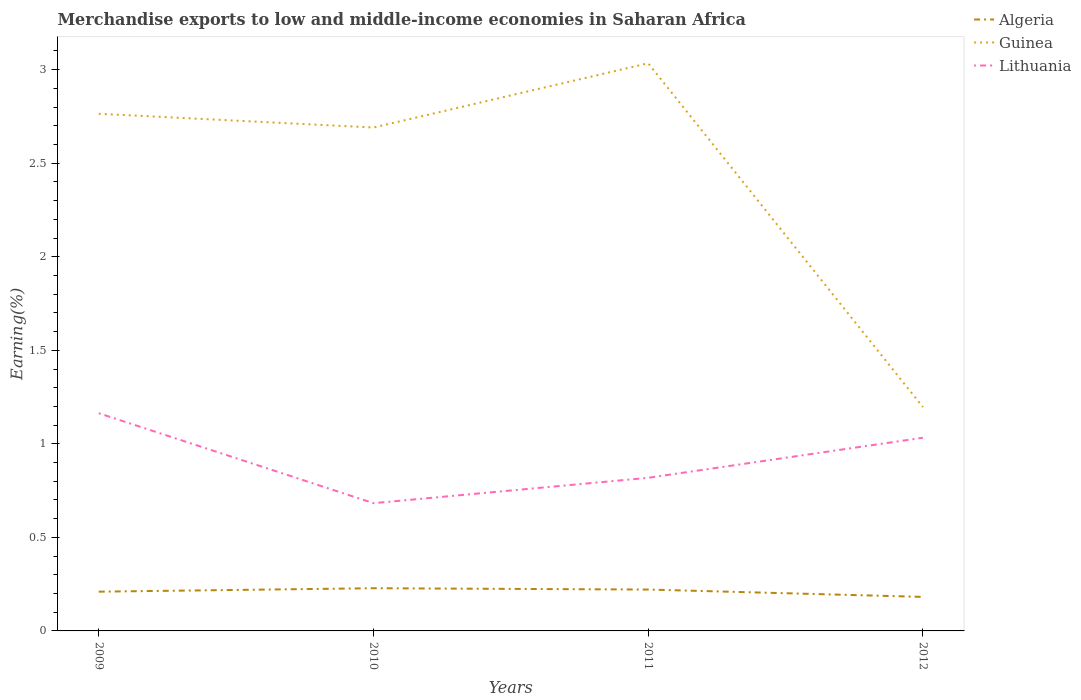Is the number of lines equal to the number of legend labels?
Provide a succinct answer. Yes. Across all years, what is the maximum percentage of amount earned from merchandise exports in Guinea?
Make the answer very short. 1.2. In which year was the percentage of amount earned from merchandise exports in Algeria maximum?
Keep it short and to the point. 2012. What is the total percentage of amount earned from merchandise exports in Lithuania in the graph?
Your answer should be very brief. 0.13. What is the difference between the highest and the second highest percentage of amount earned from merchandise exports in Algeria?
Ensure brevity in your answer.  0.05. How many lines are there?
Your response must be concise. 3. How many years are there in the graph?
Offer a very short reply. 4. Does the graph contain any zero values?
Give a very brief answer. No. How many legend labels are there?
Make the answer very short. 3. What is the title of the graph?
Provide a short and direct response. Merchandise exports to low and middle-income economies in Saharan Africa. Does "Tajikistan" appear as one of the legend labels in the graph?
Your answer should be very brief. No. What is the label or title of the X-axis?
Make the answer very short. Years. What is the label or title of the Y-axis?
Offer a terse response. Earning(%). What is the Earning(%) of Algeria in 2009?
Your response must be concise. 0.21. What is the Earning(%) of Guinea in 2009?
Offer a terse response. 2.76. What is the Earning(%) in Lithuania in 2009?
Give a very brief answer. 1.16. What is the Earning(%) of Algeria in 2010?
Ensure brevity in your answer.  0.23. What is the Earning(%) in Guinea in 2010?
Offer a terse response. 2.69. What is the Earning(%) in Lithuania in 2010?
Give a very brief answer. 0.68. What is the Earning(%) in Algeria in 2011?
Your answer should be very brief. 0.22. What is the Earning(%) in Guinea in 2011?
Your answer should be very brief. 3.03. What is the Earning(%) of Lithuania in 2011?
Give a very brief answer. 0.82. What is the Earning(%) in Algeria in 2012?
Provide a short and direct response. 0.18. What is the Earning(%) in Guinea in 2012?
Provide a short and direct response. 1.2. What is the Earning(%) of Lithuania in 2012?
Offer a terse response. 1.03. Across all years, what is the maximum Earning(%) in Algeria?
Ensure brevity in your answer.  0.23. Across all years, what is the maximum Earning(%) in Guinea?
Provide a short and direct response. 3.03. Across all years, what is the maximum Earning(%) in Lithuania?
Provide a succinct answer. 1.16. Across all years, what is the minimum Earning(%) of Algeria?
Offer a terse response. 0.18. Across all years, what is the minimum Earning(%) of Guinea?
Provide a short and direct response. 1.2. Across all years, what is the minimum Earning(%) of Lithuania?
Your answer should be compact. 0.68. What is the total Earning(%) of Algeria in the graph?
Give a very brief answer. 0.84. What is the total Earning(%) of Guinea in the graph?
Make the answer very short. 9.69. What is the total Earning(%) in Lithuania in the graph?
Ensure brevity in your answer.  3.7. What is the difference between the Earning(%) in Algeria in 2009 and that in 2010?
Make the answer very short. -0.02. What is the difference between the Earning(%) of Guinea in 2009 and that in 2010?
Your response must be concise. 0.07. What is the difference between the Earning(%) of Lithuania in 2009 and that in 2010?
Give a very brief answer. 0.48. What is the difference between the Earning(%) of Algeria in 2009 and that in 2011?
Your answer should be very brief. -0.01. What is the difference between the Earning(%) in Guinea in 2009 and that in 2011?
Keep it short and to the point. -0.27. What is the difference between the Earning(%) of Lithuania in 2009 and that in 2011?
Give a very brief answer. 0.35. What is the difference between the Earning(%) in Algeria in 2009 and that in 2012?
Your answer should be very brief. 0.03. What is the difference between the Earning(%) in Guinea in 2009 and that in 2012?
Provide a short and direct response. 1.57. What is the difference between the Earning(%) of Lithuania in 2009 and that in 2012?
Make the answer very short. 0.13. What is the difference between the Earning(%) of Algeria in 2010 and that in 2011?
Your answer should be compact. 0.01. What is the difference between the Earning(%) of Guinea in 2010 and that in 2011?
Make the answer very short. -0.34. What is the difference between the Earning(%) of Lithuania in 2010 and that in 2011?
Offer a very short reply. -0.14. What is the difference between the Earning(%) of Algeria in 2010 and that in 2012?
Your response must be concise. 0.05. What is the difference between the Earning(%) in Guinea in 2010 and that in 2012?
Your answer should be compact. 1.49. What is the difference between the Earning(%) of Lithuania in 2010 and that in 2012?
Make the answer very short. -0.35. What is the difference between the Earning(%) in Algeria in 2011 and that in 2012?
Provide a succinct answer. 0.04. What is the difference between the Earning(%) in Guinea in 2011 and that in 2012?
Your answer should be compact. 1.84. What is the difference between the Earning(%) of Lithuania in 2011 and that in 2012?
Your answer should be very brief. -0.21. What is the difference between the Earning(%) in Algeria in 2009 and the Earning(%) in Guinea in 2010?
Your response must be concise. -2.48. What is the difference between the Earning(%) of Algeria in 2009 and the Earning(%) of Lithuania in 2010?
Your response must be concise. -0.47. What is the difference between the Earning(%) in Guinea in 2009 and the Earning(%) in Lithuania in 2010?
Offer a terse response. 2.08. What is the difference between the Earning(%) in Algeria in 2009 and the Earning(%) in Guinea in 2011?
Ensure brevity in your answer.  -2.82. What is the difference between the Earning(%) in Algeria in 2009 and the Earning(%) in Lithuania in 2011?
Your response must be concise. -0.61. What is the difference between the Earning(%) of Guinea in 2009 and the Earning(%) of Lithuania in 2011?
Your answer should be very brief. 1.95. What is the difference between the Earning(%) in Algeria in 2009 and the Earning(%) in Guinea in 2012?
Make the answer very short. -0.99. What is the difference between the Earning(%) in Algeria in 2009 and the Earning(%) in Lithuania in 2012?
Your answer should be compact. -0.82. What is the difference between the Earning(%) of Guinea in 2009 and the Earning(%) of Lithuania in 2012?
Provide a short and direct response. 1.73. What is the difference between the Earning(%) in Algeria in 2010 and the Earning(%) in Guinea in 2011?
Give a very brief answer. -2.81. What is the difference between the Earning(%) in Algeria in 2010 and the Earning(%) in Lithuania in 2011?
Provide a succinct answer. -0.59. What is the difference between the Earning(%) of Guinea in 2010 and the Earning(%) of Lithuania in 2011?
Make the answer very short. 1.87. What is the difference between the Earning(%) of Algeria in 2010 and the Earning(%) of Guinea in 2012?
Your answer should be very brief. -0.97. What is the difference between the Earning(%) of Algeria in 2010 and the Earning(%) of Lithuania in 2012?
Provide a short and direct response. -0.8. What is the difference between the Earning(%) in Guinea in 2010 and the Earning(%) in Lithuania in 2012?
Your answer should be compact. 1.66. What is the difference between the Earning(%) in Algeria in 2011 and the Earning(%) in Guinea in 2012?
Provide a succinct answer. -0.98. What is the difference between the Earning(%) of Algeria in 2011 and the Earning(%) of Lithuania in 2012?
Provide a succinct answer. -0.81. What is the difference between the Earning(%) in Guinea in 2011 and the Earning(%) in Lithuania in 2012?
Give a very brief answer. 2. What is the average Earning(%) of Algeria per year?
Give a very brief answer. 0.21. What is the average Earning(%) of Guinea per year?
Give a very brief answer. 2.42. What is the average Earning(%) of Lithuania per year?
Give a very brief answer. 0.92. In the year 2009, what is the difference between the Earning(%) of Algeria and Earning(%) of Guinea?
Your answer should be very brief. -2.55. In the year 2009, what is the difference between the Earning(%) of Algeria and Earning(%) of Lithuania?
Provide a succinct answer. -0.95. In the year 2009, what is the difference between the Earning(%) in Guinea and Earning(%) in Lithuania?
Ensure brevity in your answer.  1.6. In the year 2010, what is the difference between the Earning(%) in Algeria and Earning(%) in Guinea?
Ensure brevity in your answer.  -2.46. In the year 2010, what is the difference between the Earning(%) of Algeria and Earning(%) of Lithuania?
Ensure brevity in your answer.  -0.45. In the year 2010, what is the difference between the Earning(%) in Guinea and Earning(%) in Lithuania?
Your response must be concise. 2.01. In the year 2011, what is the difference between the Earning(%) of Algeria and Earning(%) of Guinea?
Ensure brevity in your answer.  -2.81. In the year 2011, what is the difference between the Earning(%) of Algeria and Earning(%) of Lithuania?
Give a very brief answer. -0.6. In the year 2011, what is the difference between the Earning(%) in Guinea and Earning(%) in Lithuania?
Offer a terse response. 2.22. In the year 2012, what is the difference between the Earning(%) of Algeria and Earning(%) of Guinea?
Provide a succinct answer. -1.01. In the year 2012, what is the difference between the Earning(%) of Algeria and Earning(%) of Lithuania?
Ensure brevity in your answer.  -0.85. In the year 2012, what is the difference between the Earning(%) in Guinea and Earning(%) in Lithuania?
Provide a succinct answer. 0.16. What is the ratio of the Earning(%) of Algeria in 2009 to that in 2010?
Offer a very short reply. 0.92. What is the ratio of the Earning(%) of Guinea in 2009 to that in 2010?
Offer a very short reply. 1.03. What is the ratio of the Earning(%) in Lithuania in 2009 to that in 2010?
Make the answer very short. 1.7. What is the ratio of the Earning(%) of Algeria in 2009 to that in 2011?
Provide a succinct answer. 0.95. What is the ratio of the Earning(%) in Guinea in 2009 to that in 2011?
Provide a short and direct response. 0.91. What is the ratio of the Earning(%) in Lithuania in 2009 to that in 2011?
Your answer should be compact. 1.42. What is the ratio of the Earning(%) in Algeria in 2009 to that in 2012?
Give a very brief answer. 1.15. What is the ratio of the Earning(%) in Guinea in 2009 to that in 2012?
Your response must be concise. 2.31. What is the ratio of the Earning(%) in Lithuania in 2009 to that in 2012?
Your response must be concise. 1.13. What is the ratio of the Earning(%) in Algeria in 2010 to that in 2011?
Ensure brevity in your answer.  1.03. What is the ratio of the Earning(%) of Guinea in 2010 to that in 2011?
Ensure brevity in your answer.  0.89. What is the ratio of the Earning(%) of Lithuania in 2010 to that in 2011?
Ensure brevity in your answer.  0.83. What is the ratio of the Earning(%) in Algeria in 2010 to that in 2012?
Offer a very short reply. 1.26. What is the ratio of the Earning(%) of Guinea in 2010 to that in 2012?
Ensure brevity in your answer.  2.25. What is the ratio of the Earning(%) of Lithuania in 2010 to that in 2012?
Your answer should be very brief. 0.66. What is the ratio of the Earning(%) of Algeria in 2011 to that in 2012?
Make the answer very short. 1.22. What is the ratio of the Earning(%) in Guinea in 2011 to that in 2012?
Your answer should be very brief. 2.54. What is the ratio of the Earning(%) in Lithuania in 2011 to that in 2012?
Give a very brief answer. 0.79. What is the difference between the highest and the second highest Earning(%) of Algeria?
Ensure brevity in your answer.  0.01. What is the difference between the highest and the second highest Earning(%) in Guinea?
Ensure brevity in your answer.  0.27. What is the difference between the highest and the second highest Earning(%) of Lithuania?
Provide a short and direct response. 0.13. What is the difference between the highest and the lowest Earning(%) in Algeria?
Your answer should be compact. 0.05. What is the difference between the highest and the lowest Earning(%) in Guinea?
Your answer should be very brief. 1.84. What is the difference between the highest and the lowest Earning(%) in Lithuania?
Your answer should be compact. 0.48. 